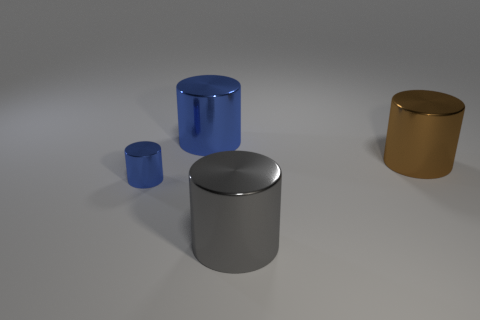There is a blue metal cylinder in front of the large thing that is behind the large brown shiny object; what size is it?
Ensure brevity in your answer.  Small. What number of big objects are either gray cylinders or brown objects?
Your response must be concise. 2. What number of other things are there of the same color as the small metal cylinder?
Make the answer very short. 1. There is a metal cylinder in front of the small blue cylinder; is its size the same as the blue metallic cylinder to the right of the small blue metallic cylinder?
Make the answer very short. Yes. Are the big gray object and the large blue cylinder that is to the left of the brown shiny cylinder made of the same material?
Your answer should be compact. Yes. Is the number of blue cylinders in front of the large brown cylinder greater than the number of cylinders that are on the left side of the tiny metallic cylinder?
Keep it short and to the point. Yes. There is a large metallic object that is on the left side of the large gray object that is on the right side of the tiny blue cylinder; what color is it?
Keep it short and to the point. Blue. How many spheres are either big gray metallic things or blue things?
Keep it short and to the point. 0. What number of blue cylinders are left of the big blue cylinder and behind the brown metallic object?
Make the answer very short. 0. There is a object left of the big blue object; what color is it?
Give a very brief answer. Blue. 